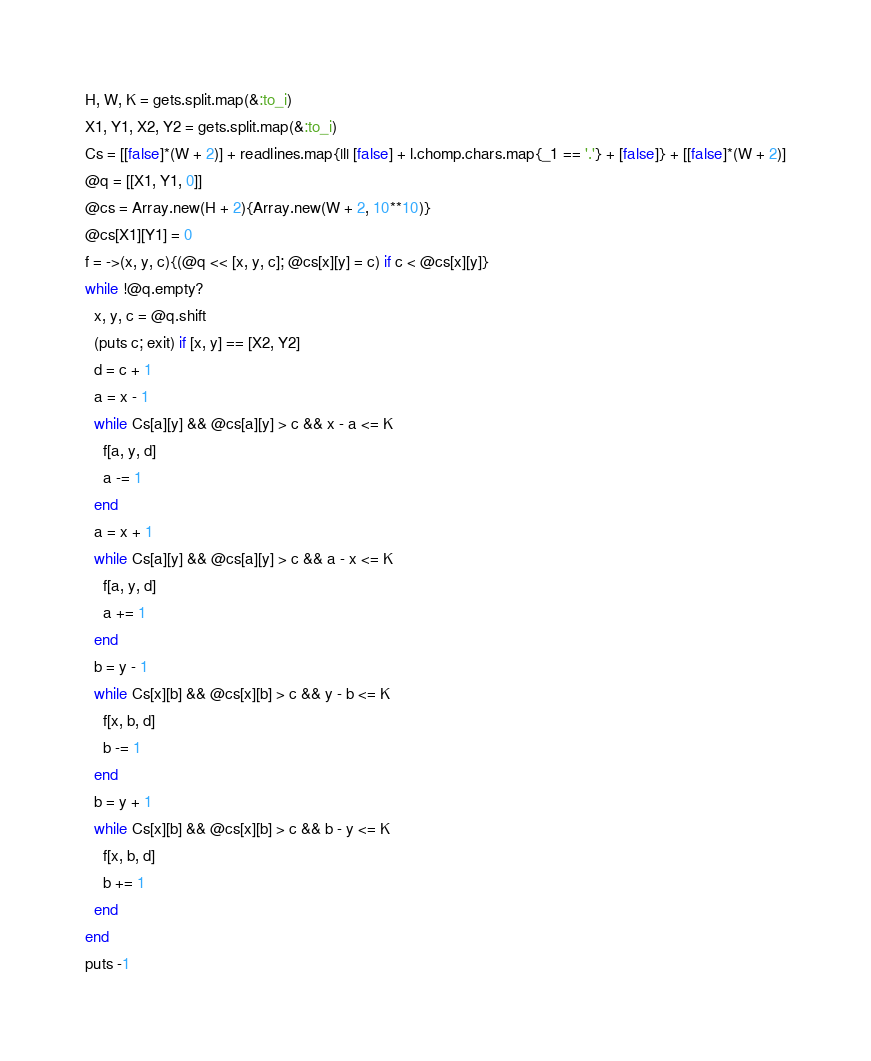<code> <loc_0><loc_0><loc_500><loc_500><_Ruby_>H, W, K = gets.split.map(&:to_i)
X1, Y1, X2, Y2 = gets.split.map(&:to_i)
Cs = [[false]*(W + 2)] + readlines.map{|l| [false] + l.chomp.chars.map{_1 == '.'} + [false]} + [[false]*(W + 2)]
@q = [[X1, Y1, 0]]
@cs = Array.new(H + 2){Array.new(W + 2, 10**10)}
@cs[X1][Y1] = 0
f = ->(x, y, c){(@q << [x, y, c]; @cs[x][y] = c) if c < @cs[x][y]}
while !@q.empty?
  x, y, c = @q.shift
  (puts c; exit) if [x, y] == [X2, Y2]
  d = c + 1
  a = x - 1
  while Cs[a][y] && @cs[a][y] > c && x - a <= K
    f[a, y, d]
    a -= 1
  end
  a = x + 1
  while Cs[a][y] && @cs[a][y] > c && a - x <= K
    f[a, y, d]
    a += 1
  end
  b = y - 1
  while Cs[x][b] && @cs[x][b] > c && y - b <= K
    f[x, b, d]
    b -= 1
  end
  b = y + 1
  while Cs[x][b] && @cs[x][b] > c && b - y <= K
    f[x, b, d]
    b += 1
  end
end
puts -1</code> 